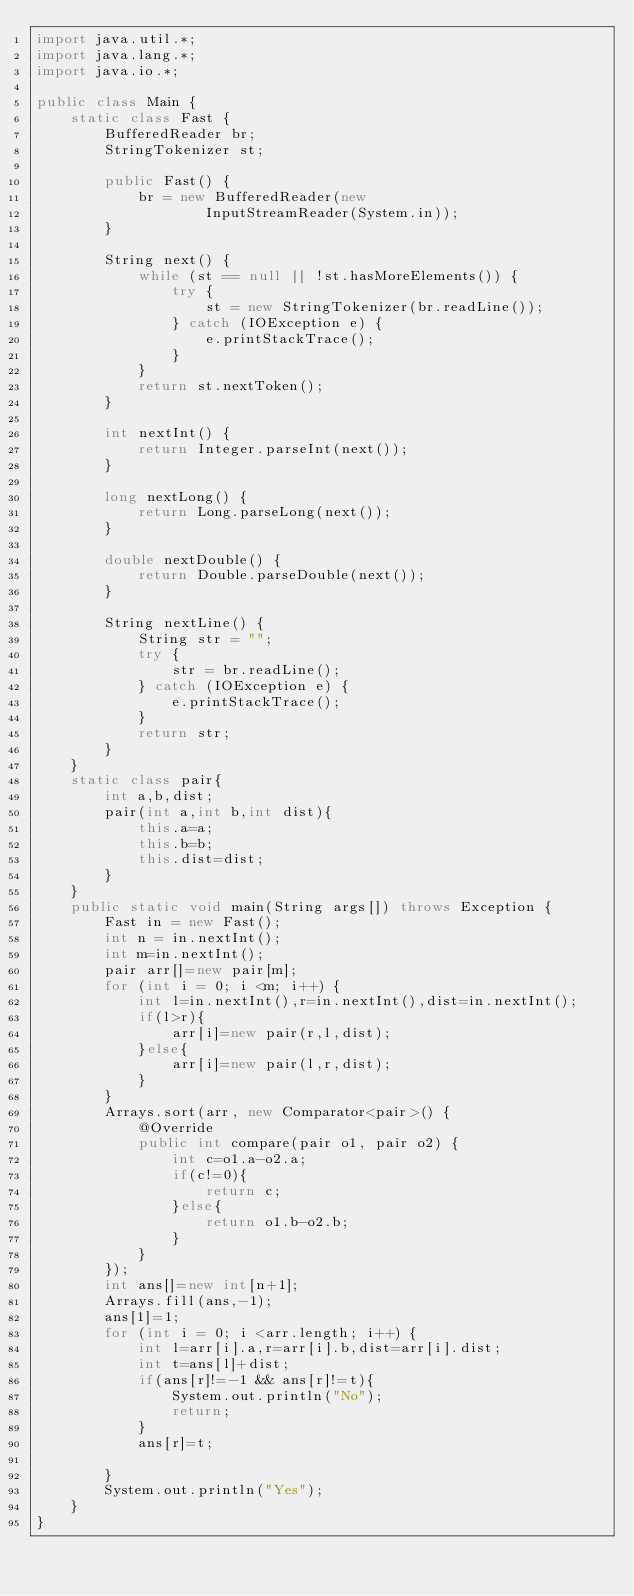<code> <loc_0><loc_0><loc_500><loc_500><_Java_>import java.util.*;
import java.lang.*;
import java.io.*;

public class Main {
    static class Fast {
        BufferedReader br;
        StringTokenizer st;

        public Fast() {
            br = new BufferedReader(new
                    InputStreamReader(System.in));
        }

        String next() {
            while (st == null || !st.hasMoreElements()) {
                try {
                    st = new StringTokenizer(br.readLine());
                } catch (IOException e) {
                    e.printStackTrace();
                }
            }
            return st.nextToken();
        }

        int nextInt() {
            return Integer.parseInt(next());
        }

        long nextLong() {
            return Long.parseLong(next());
        }

        double nextDouble() {
            return Double.parseDouble(next());
        }

        String nextLine() {
            String str = "";
            try {
                str = br.readLine();
            } catch (IOException e) {
                e.printStackTrace();
            }
            return str;
        }
    }
    static class pair{
        int a,b,dist;
        pair(int a,int b,int dist){
            this.a=a;
            this.b=b;
            this.dist=dist;
        }
    }
    public static void main(String args[]) throws Exception {
        Fast in = new Fast();
        int n = in.nextInt();
        int m=in.nextInt();
        pair arr[]=new pair[m];
        for (int i = 0; i <m; i++) {
            int l=in.nextInt(),r=in.nextInt(),dist=in.nextInt();
            if(l>r){
                arr[i]=new pair(r,l,dist);
            }else{
                arr[i]=new pair(l,r,dist);
            }
        }
        Arrays.sort(arr, new Comparator<pair>() {
            @Override
            public int compare(pair o1, pair o2) {
                int c=o1.a-o2.a;
                if(c!=0){
                    return c;
                }else{
                    return o1.b-o2.b;
                }
            }
        });
        int ans[]=new int[n+1];
        Arrays.fill(ans,-1);
        ans[1]=1;
        for (int i = 0; i <arr.length; i++) {
            int l=arr[i].a,r=arr[i].b,dist=arr[i].dist;
            int t=ans[l]+dist;
            if(ans[r]!=-1 && ans[r]!=t){
                System.out.println("No");
                return;
            }
            ans[r]=t;

        }
        System.out.println("Yes");
    }
}




</code> 